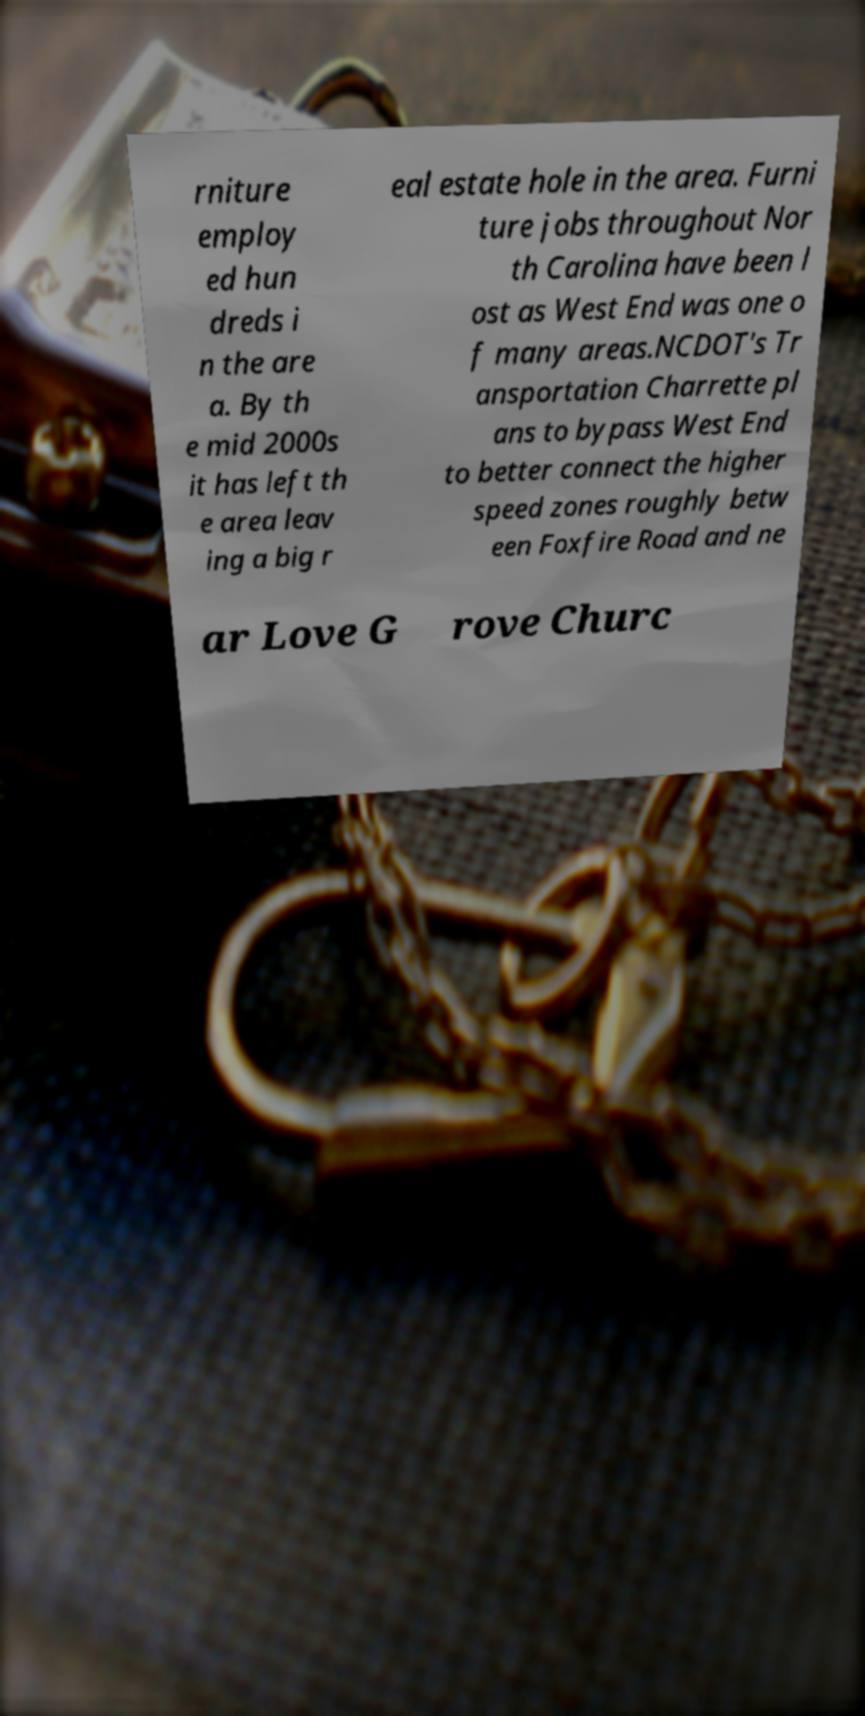Please identify and transcribe the text found in this image. rniture employ ed hun dreds i n the are a. By th e mid 2000s it has left th e area leav ing a big r eal estate hole in the area. Furni ture jobs throughout Nor th Carolina have been l ost as West End was one o f many areas.NCDOT's Tr ansportation Charrette pl ans to bypass West End to better connect the higher speed zones roughly betw een Foxfire Road and ne ar Love G rove Churc 